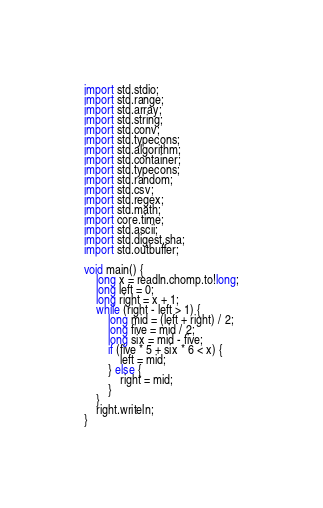Convert code to text. <code><loc_0><loc_0><loc_500><loc_500><_D_>import std.stdio;
import std.range;
import std.array;
import std.string;
import std.conv;
import std.typecons;
import std.algorithm;
import std.container;
import std.typecons;
import std.random;
import std.csv;
import std.regex;
import std.math;
import core.time;
import std.ascii;
import std.digest.sha;
import std.outbuffer;

void main() {
	long x = readln.chomp.to!long;
	long left = 0;
	long right = x + 1;
	while (right - left > 1) {
		long mid = (left + right) / 2;
		long five = mid / 2;
		long six = mid - five;
		if (five * 5 + six * 6 < x) {
			left = mid;
		} else {
			right = mid;
		}
	}
	right.writeln;
}

</code> 